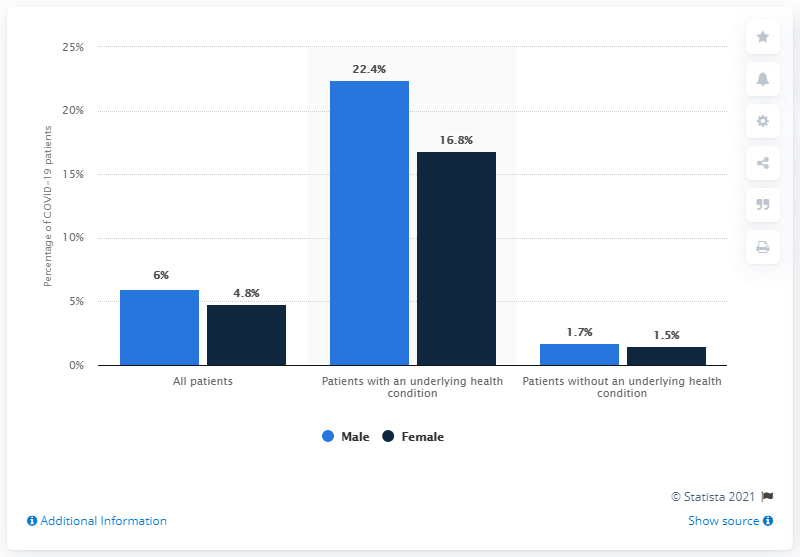Identify some key points in this picture. During the period of January 22 to May 30, 2020, it is estimated that approximately 6% of males died from COVID-19. The percentage of the highest blue bar is 22.4%. The average between male and female patients with an underlying health condition is 19.6. During the period of January 22 to May 30, 2020, 4.8% of females tested positive for COVID-19. 